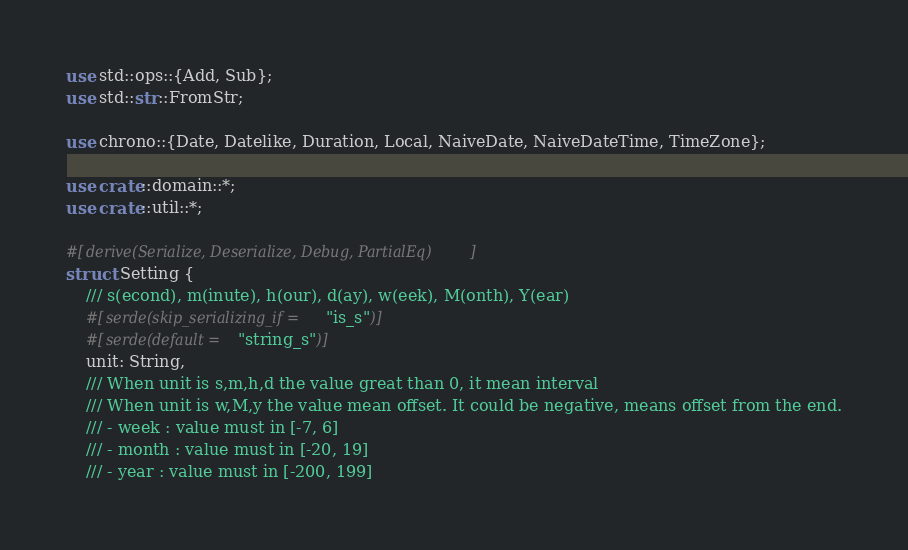Convert code to text. <code><loc_0><loc_0><loc_500><loc_500><_Rust_>use std::ops::{Add, Sub};
use std::str::FromStr;

use chrono::{Date, Datelike, Duration, Local, NaiveDate, NaiveDateTime, TimeZone};

use crate::domain::*;
use crate::util::*;

#[derive(Serialize, Deserialize, Debug, PartialEq)]
struct Setting {
    /// s(econd), m(inute), h(our), d(ay), w(eek), M(onth), Y(ear)
    #[serde(skip_serializing_if = "is_s")]
    #[serde(default = "string_s")]
    unit: String,
    /// When unit is s,m,h,d the value great than 0, it mean interval
    /// When unit is w,M,y the value mean offset. It could be negative, means offset from the end.
    /// - week : value must in [-7, 6]
    /// - month : value must in [-20, 19]
    /// - year : value must in [-200, 199]</code> 